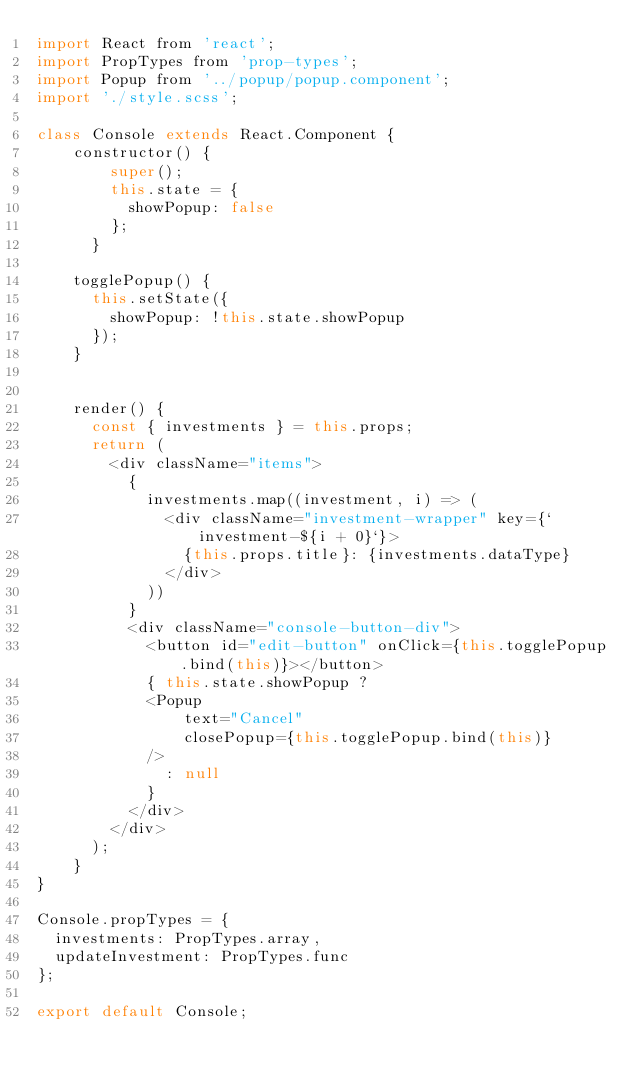<code> <loc_0><loc_0><loc_500><loc_500><_JavaScript_>import React from 'react';
import PropTypes from 'prop-types';
import Popup from '../popup/popup.component';
import './style.scss';

class Console extends React.Component {
    constructor() {
        super();
        this.state = {
          showPopup: false
        };
      }

    togglePopup() {
      this.setState({
        showPopup: !this.state.showPopup
      });
    }


    render() {
      const { investments } = this.props;
      return (
        <div className="items">
          {
            investments.map((investment, i) => (
              <div className="investment-wrapper" key={`investment-${i + 0}`}>
                {this.props.title}: {investments.dataType}
              </div>
            ))
          }
          <div className="console-button-div">
            <button id="edit-button" onClick={this.togglePopup.bind(this)}></button>
            { this.state.showPopup ? 
            <Popup
                text="Cancel"
                closePopup={this.togglePopup.bind(this)}
            />
              : null
            }
          </div>
        </div>
      );
    }
}

Console.propTypes = {
  investments: PropTypes.array,
  updateInvestment: PropTypes.func
};

export default Console;
</code> 